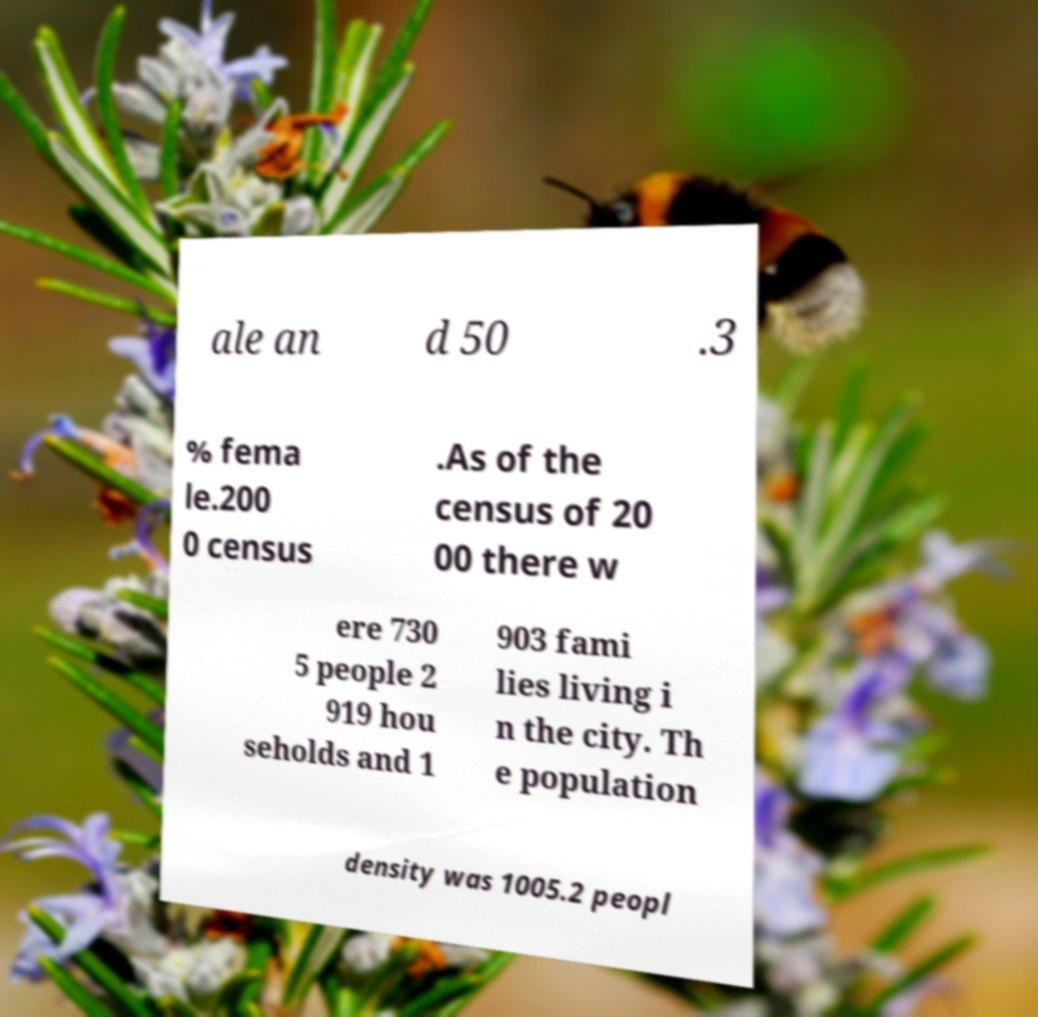Please identify and transcribe the text found in this image. ale an d 50 .3 % fema le.200 0 census .As of the census of 20 00 there w ere 730 5 people 2 919 hou seholds and 1 903 fami lies living i n the city. Th e population density was 1005.2 peopl 